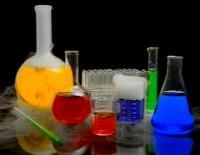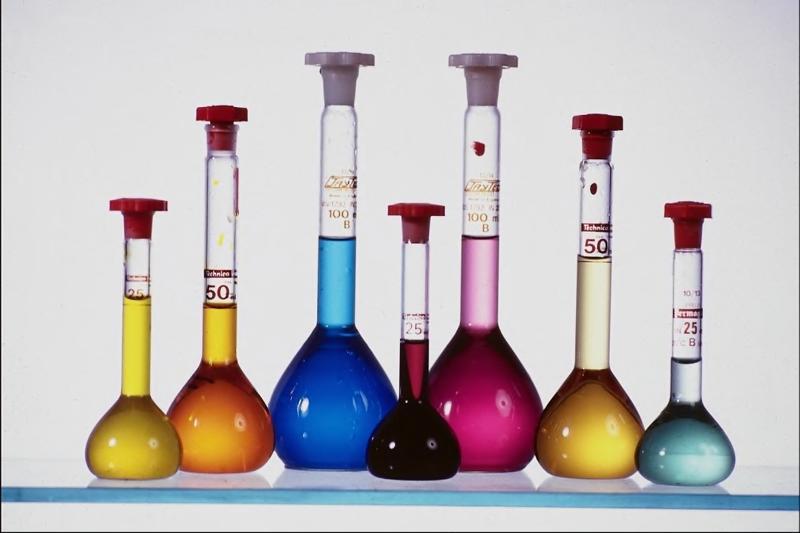The first image is the image on the left, the second image is the image on the right. For the images shown, is this caption "One image features exactly five beakers of different liquid colors, in the same shape but different sizes." true? Answer yes or no. No. The first image is the image on the left, the second image is the image on the right. Examine the images to the left and right. Is the description "There are at least 11 beakers with there pourer facing left." accurate? Answer yes or no. No. 